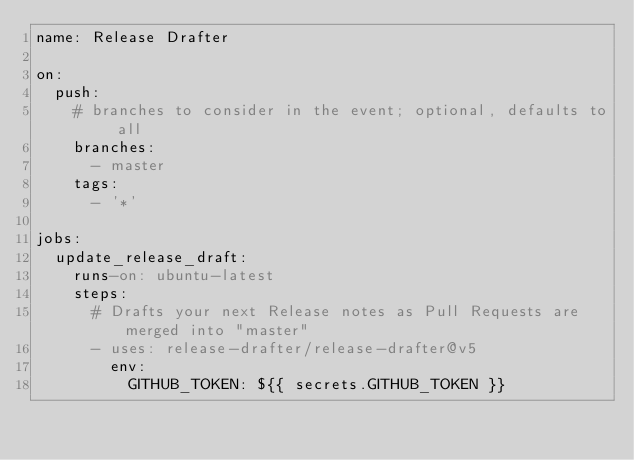<code> <loc_0><loc_0><loc_500><loc_500><_YAML_>name: Release Drafter

on:
  push:
    # branches to consider in the event; optional, defaults to all
    branches:
      - master
    tags:
      - '*'

jobs:
  update_release_draft:
    runs-on: ubuntu-latest
    steps:
      # Drafts your next Release notes as Pull Requests are merged into "master"
      - uses: release-drafter/release-drafter@v5
        env:
          GITHUB_TOKEN: ${{ secrets.GITHUB_TOKEN }}
</code> 